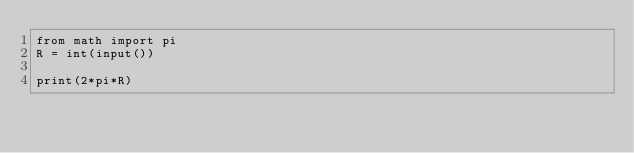Convert code to text. <code><loc_0><loc_0><loc_500><loc_500><_Python_>from math import pi
R = int(input())

print(2*pi*R)</code> 